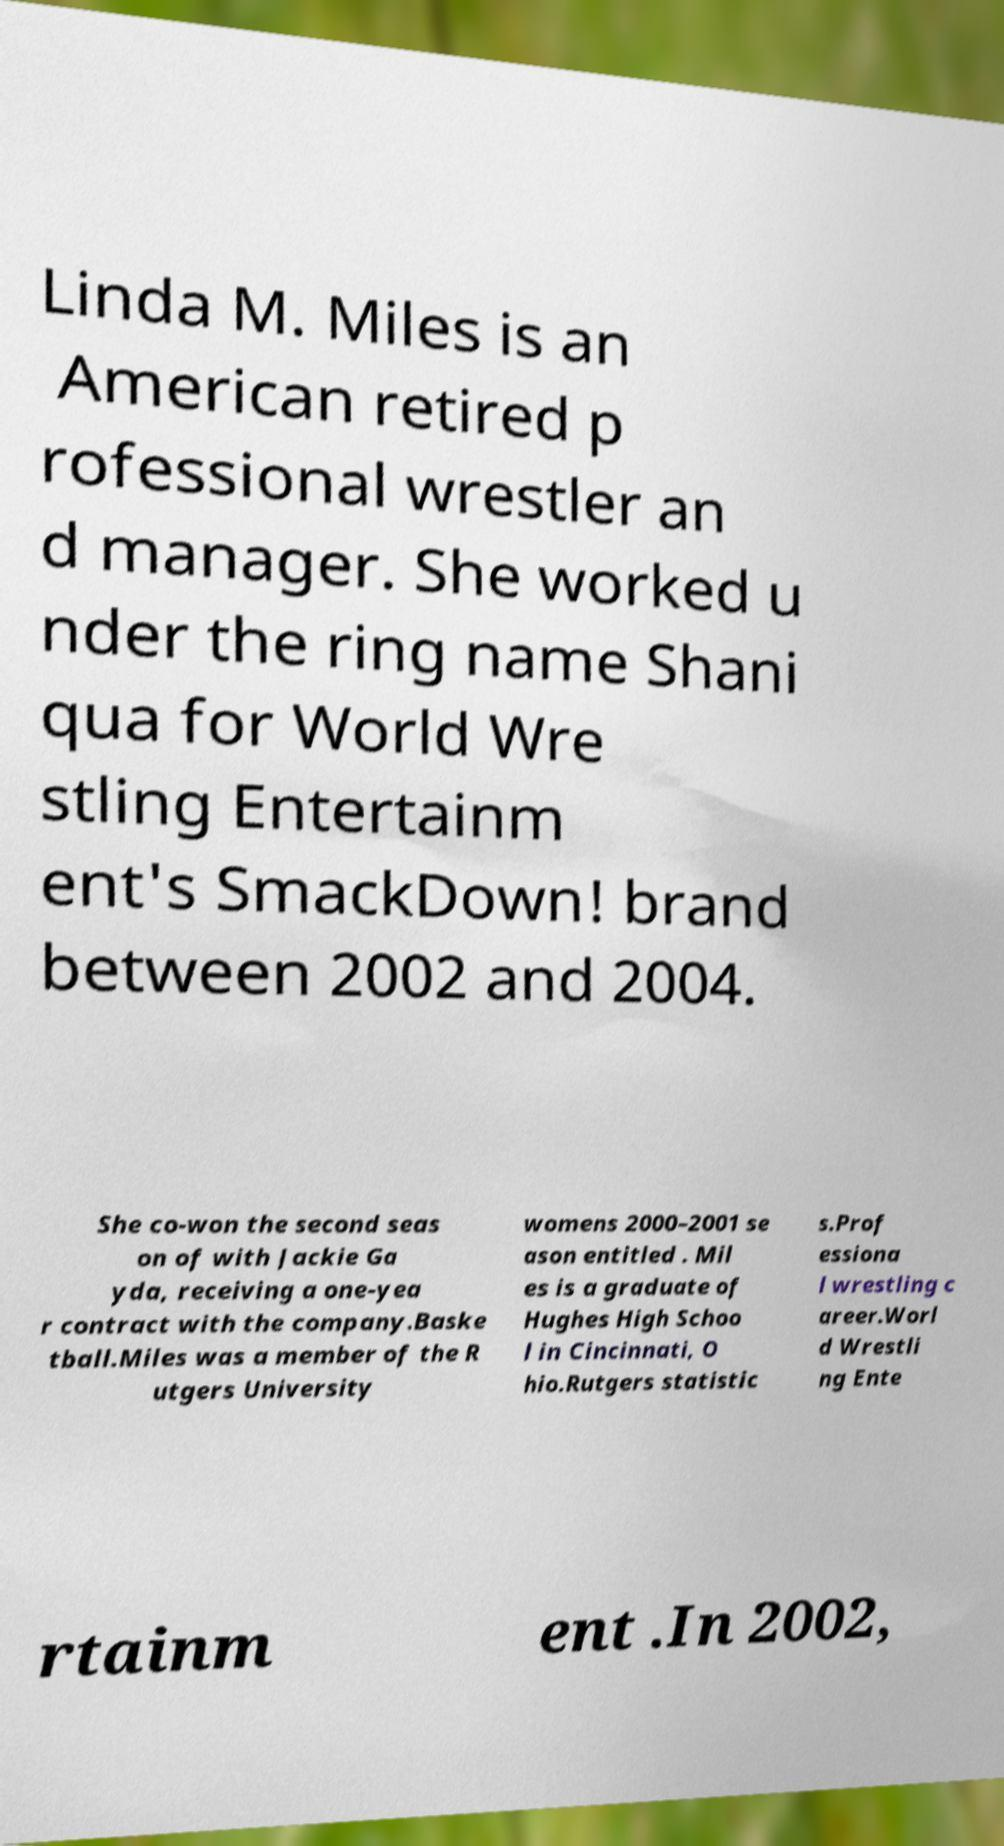What messages or text are displayed in this image? I need them in a readable, typed format. Linda M. Miles is an American retired p rofessional wrestler an d manager. She worked u nder the ring name Shani qua for World Wre stling Entertainm ent's SmackDown! brand between 2002 and 2004. She co-won the second seas on of with Jackie Ga yda, receiving a one-yea r contract with the company.Baske tball.Miles was a member of the R utgers University womens 2000–2001 se ason entitled . Mil es is a graduate of Hughes High Schoo l in Cincinnati, O hio.Rutgers statistic s.Prof essiona l wrestling c areer.Worl d Wrestli ng Ente rtainm ent .In 2002, 